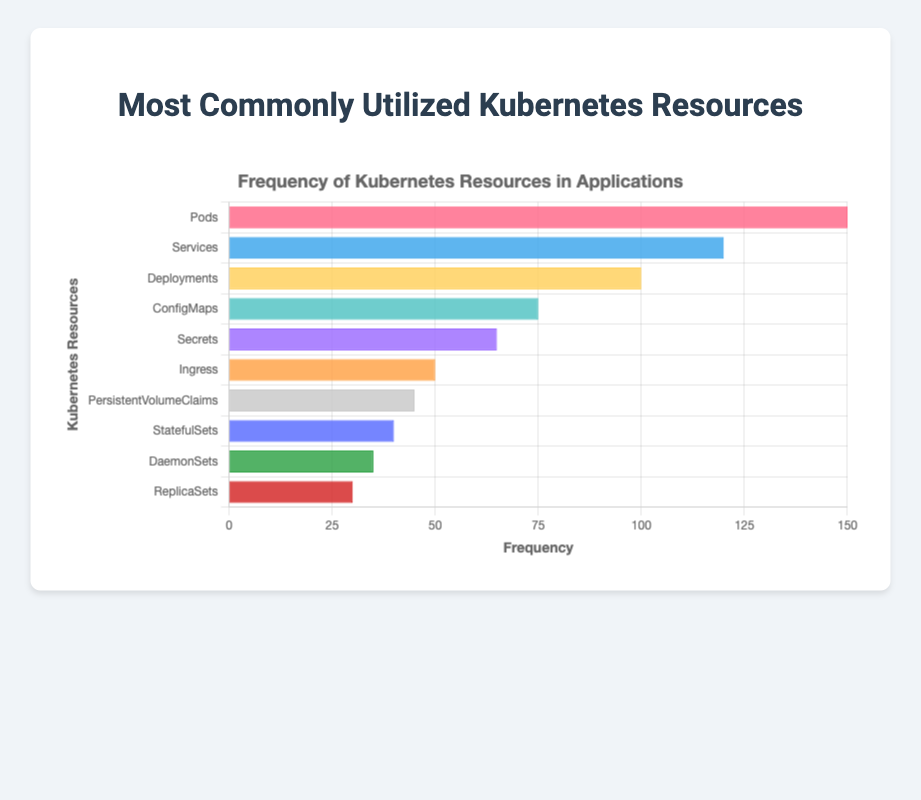Which Kubernetes resource has the highest frequency? By visually inspecting the horizontal bar with the greatest length, we see that "Pods" have the highest frequency count.
Answer: Pods Which resource has a frequency of less than 50? We need to find the bars that are shorter than the value representing 50 on the x-axis. "PersistentVolumeClaims," "StatefulSets," "DaemonSets," and "ReplicaSets" fit this criterion.
Answer: PersistentVolumeClaims, StatefulSets, DaemonSets, ReplicaSets What is the combined frequency of "Deployments" and "Services"? By adding the frequency counts for "Deployments" (100) and "Services" (120), we get 100 + 120 = 220.
Answer: 220 How many more times are "ConfigMaps" used compared to "ReplicaSets"? By subtracting the frequency count of "ReplicaSets" (30) from that of "ConfigMaps" (75), we get 75 - 30 = 45.
Answer: 45 Arrange the resources in order of decreasing frequency. We list the resources starting from the longest bar to the shortest: "Pods," "Services," "Deployments," "ConfigMaps," "Secrets," "Ingress," "PersistentVolumeClaims," "StatefulSets," "DaemonSets," "ReplicaSets."
Answer: Pods, Services, Deployments, ConfigMaps, Secrets, Ingress, PersistentVolumeClaims, StatefulSets, DaemonSets, ReplicaSets Which resources have a frequency count greater than or equal to 75? By identifying the bars that are at least 75 units long on the x-axis, we find "Pods," "Services," "Deployments," and "ConfigMaps."
Answer: Pods, Services, Deployments, ConfigMaps What is the difference in frequency between "Ingress" and "Secrets"? By subtracting the frequency of "Ingress" (50) from that of "Secrets" (65), we get 65 - 50 = 15.
Answer: 15 What is the total frequency of all the resources? By summing up the frequency counts of all resources, we get: 150 + 120 + 100 + 75 + 65 + 50 + 45 + 40 + 35 + 30 = 710.
Answer: 710 